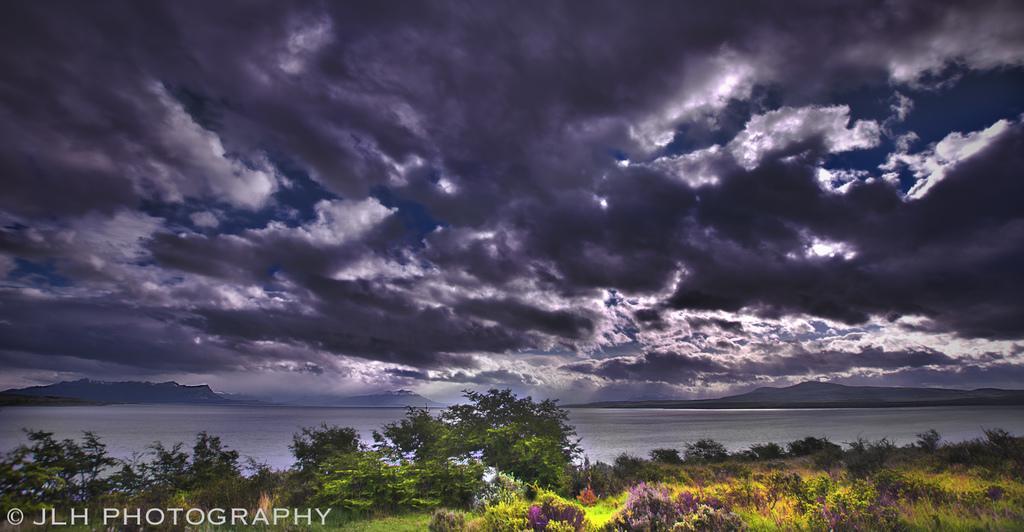How would you summarize this image in a sentence or two? This image is taken outdoors. At the top of the image there is the sky with clouds. The sky is dark. In the background there are a few hills. At the bottom of the image is a ground with grass on it and there are many plants on the ground. In the middle of the image there is a river with water. 